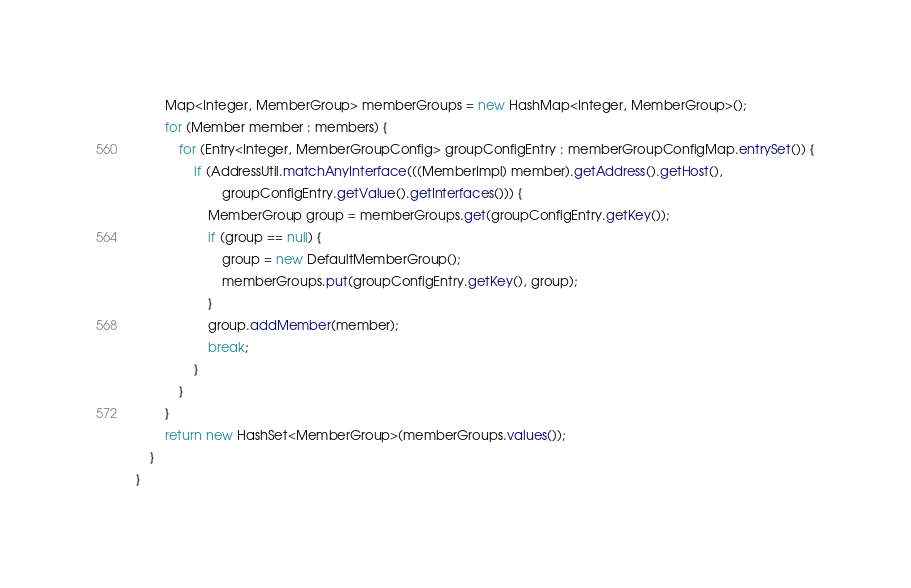Convert code to text. <code><loc_0><loc_0><loc_500><loc_500><_Java_>        Map<Integer, MemberGroup> memberGroups = new HashMap<Integer, MemberGroup>();
        for (Member member : members) {
            for (Entry<Integer, MemberGroupConfig> groupConfigEntry : memberGroupConfigMap.entrySet()) {
                if (AddressUtil.matchAnyInterface(((MemberImpl) member).getAddress().getHost(),
                        groupConfigEntry.getValue().getInterfaces())) {
                    MemberGroup group = memberGroups.get(groupConfigEntry.getKey());
                    if (group == null) {
                        group = new DefaultMemberGroup();
                        memberGroups.put(groupConfigEntry.getKey(), group);
                    }
                    group.addMember(member);
                    break;
                }
            }
        }
        return new HashSet<MemberGroup>(memberGroups.values());
    }
}
</code> 